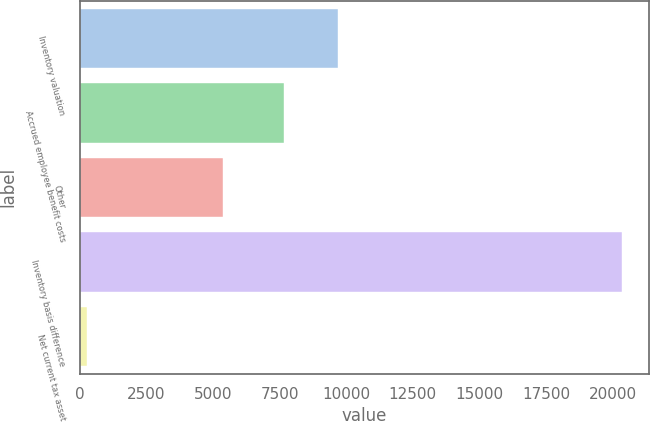<chart> <loc_0><loc_0><loc_500><loc_500><bar_chart><fcel>Inventory valuation<fcel>Accrued employee benefit costs<fcel>Other<fcel>Inventory basis difference<fcel>Net current tax asset<nl><fcel>9675.5<fcel>7670<fcel>5367<fcel>20332<fcel>277<nl></chart> 